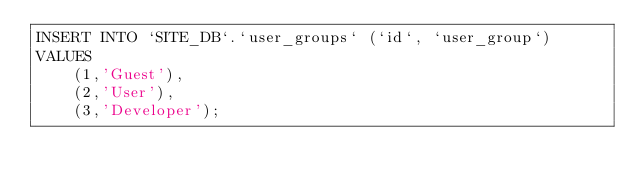Convert code to text. <code><loc_0><loc_0><loc_500><loc_500><_SQL_>INSERT INTO `SITE_DB`.`user_groups` (`id`, `user_group`)
VALUES
	(1,'Guest'),
	(2,'User'),
	(3,'Developer');
</code> 